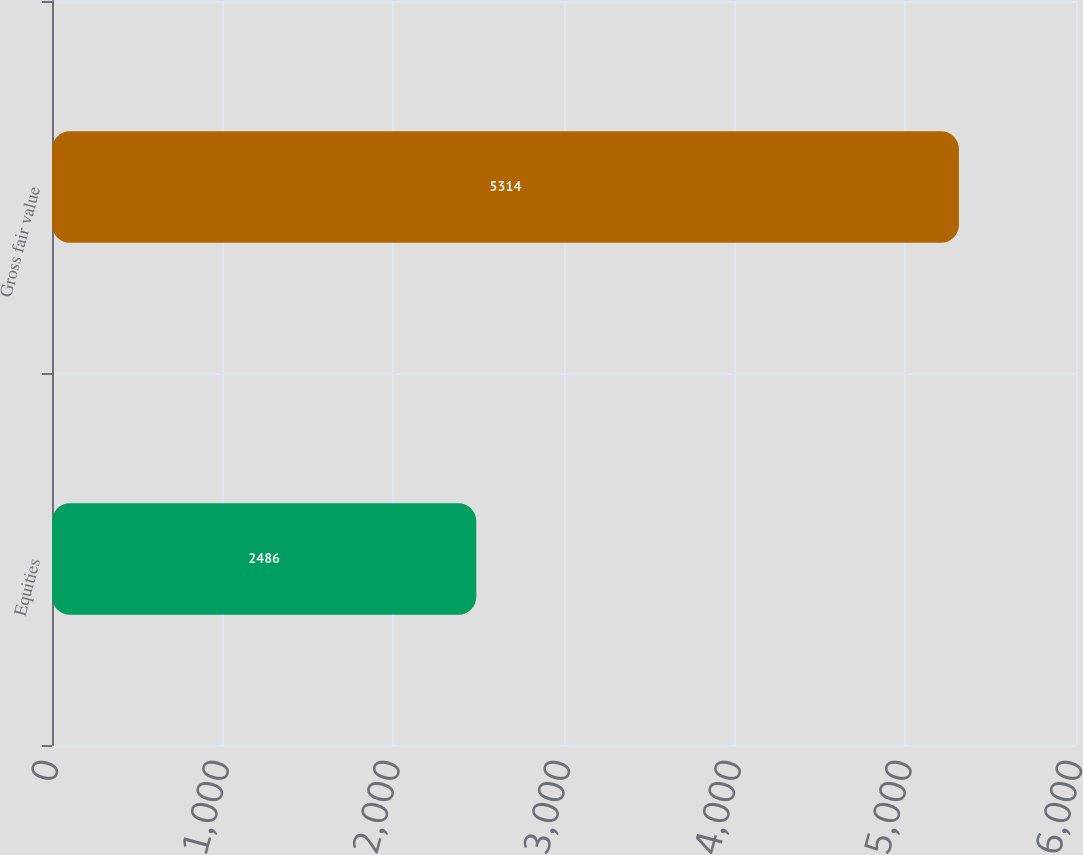<chart> <loc_0><loc_0><loc_500><loc_500><bar_chart><fcel>Equities<fcel>Gross fair value<nl><fcel>2486<fcel>5314<nl></chart> 